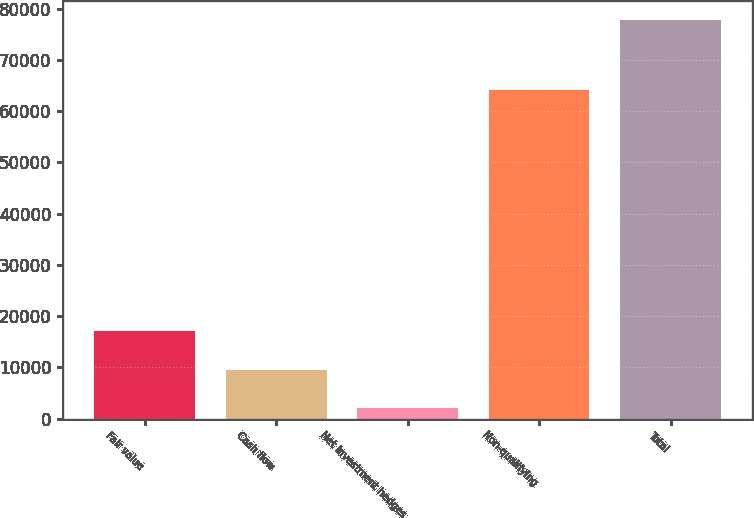Convert chart. <chart><loc_0><loc_0><loc_500><loc_500><bar_chart><fcel>Fair value<fcel>Cash flow<fcel>Net investment hedges<fcel>Non-qualifying<fcel>Total<nl><fcel>17136.8<fcel>9567.9<fcel>1999<fcel>64155<fcel>77688<nl></chart> 